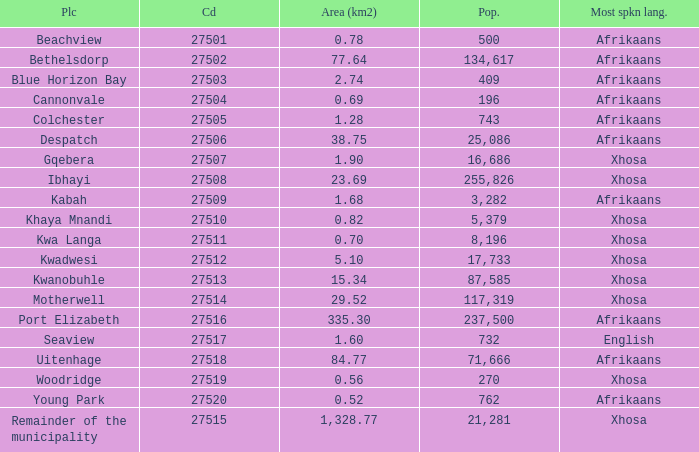What is the lowest code number for the remainder of the municipality that has an area bigger than 15.34 squared kilometers, a population greater than 762 and a language of xhosa spoken? 27515.0. 